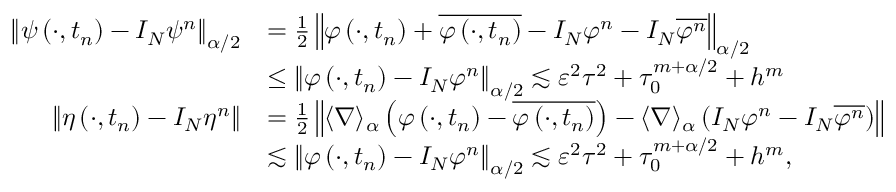<formula> <loc_0><loc_0><loc_500><loc_500>\begin{array} { r l } { \left \| \psi \left ( \cdot , t _ { n } \right ) - I _ { N } \psi ^ { n } \right \| _ { \alpha / 2 } } & { = \frac { 1 } { 2 } \left \| \varphi \left ( \cdot , t _ { n } \right ) + \overline { { \varphi \left ( \cdot , t _ { n } \right ) } } - I _ { N } \varphi ^ { n } - I _ { N } \overline { { \varphi ^ { n } } } \right \| _ { \alpha / 2 } } \\ & { \leq \left \| \varphi \left ( \cdot , t _ { n } \right ) - I _ { N } \varphi ^ { n } \right \| _ { \alpha / 2 } \lesssim \varepsilon ^ { 2 } \tau ^ { 2 } + \tau _ { 0 } ^ { m + \alpha / 2 } + h ^ { m } } \\ { \left \| \eta \left ( \cdot , t _ { n } \right ) - I _ { N } \eta ^ { n } \right \| } & { = \frac { 1 } { 2 } \left \| \langle \nabla \rangle _ { \alpha } \left ( \varphi \left ( \cdot , t _ { n } \right ) - \overline { { \varphi \left ( \cdot , t _ { n } \right ) } } \right ) - \langle \nabla \rangle _ { \alpha } \left ( I _ { N } \varphi ^ { n } - I _ { N } \overline { { \varphi ^ { n } } } \right ) \right \| } \\ & { \lesssim \left \| \varphi \left ( \cdot , t _ { n } \right ) - I _ { N } \varphi ^ { n } \right \| _ { \alpha / 2 } \lesssim \varepsilon ^ { 2 } \tau ^ { 2 } + \tau _ { 0 } ^ { m + \alpha / 2 } + h ^ { m } , } \end{array}</formula> 